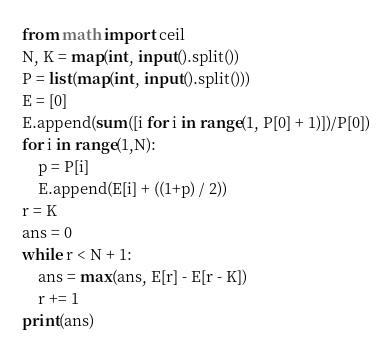Convert code to text. <code><loc_0><loc_0><loc_500><loc_500><_Python_>from math import ceil
N, K = map(int, input().split())
P = list(map(int, input().split()))
E = [0]
E.append(sum([i for i in range(1, P[0] + 1)])/P[0])
for i in range(1,N):
    p = P[i]
    E.append(E[i] + ((1+p) / 2))
r = K
ans = 0
while r < N + 1:
    ans = max(ans, E[r] - E[r - K])
    r += 1
print(ans)</code> 